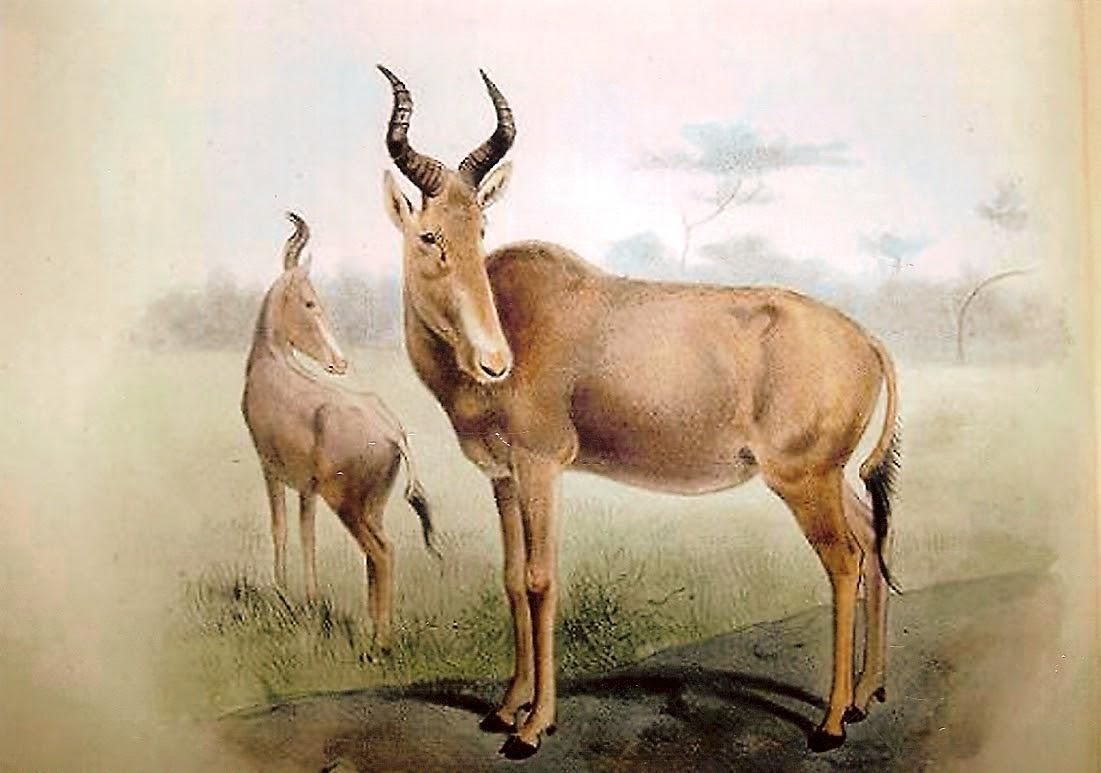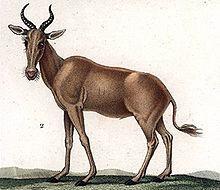The first image is the image on the left, the second image is the image on the right. Analyze the images presented: Is the assertion "There are three gazelle-type creatures standing." valid? Answer yes or no. Yes. 